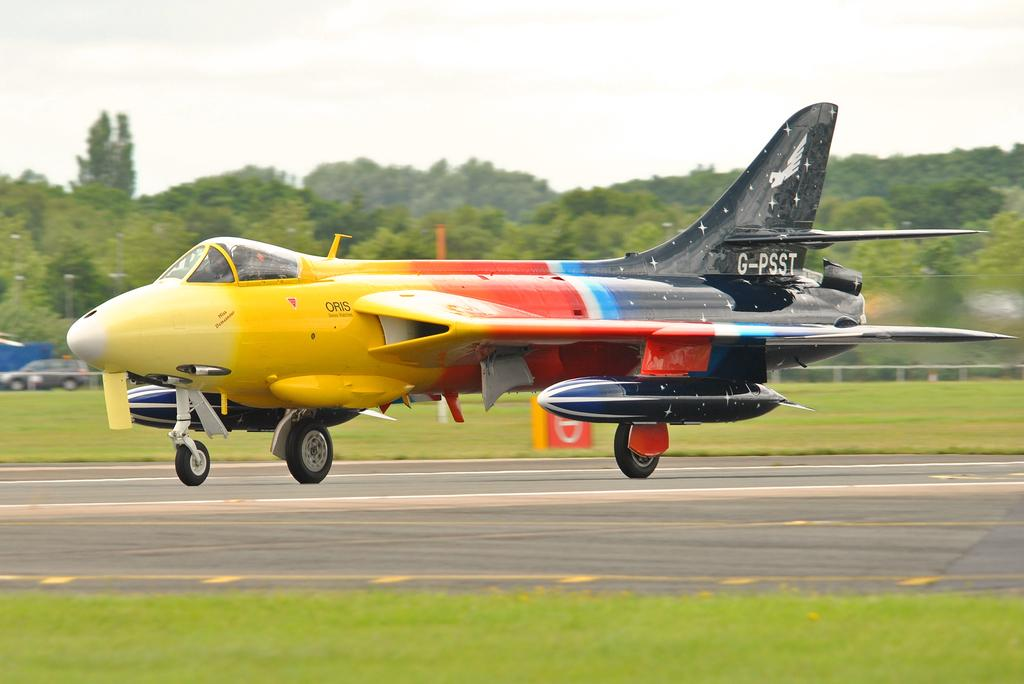<image>
Provide a brief description of the given image. a multicolor fighter plane with tail number G-PSST landing 